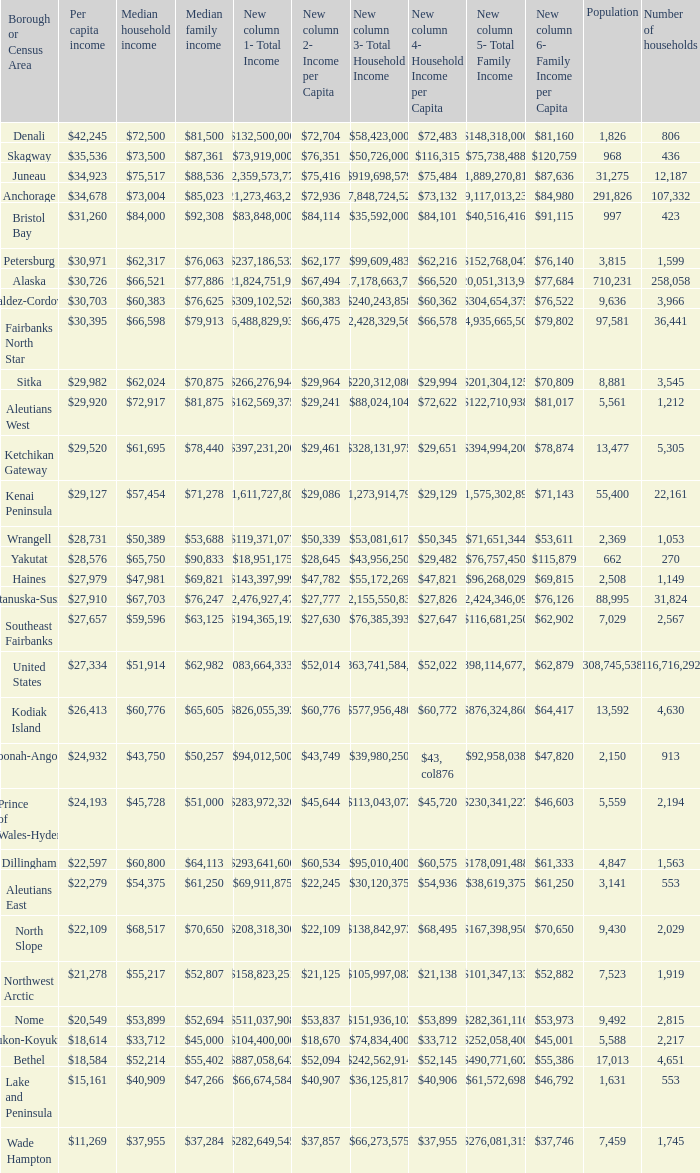What is the population of the area with a median family income of $71,278? 1.0. 